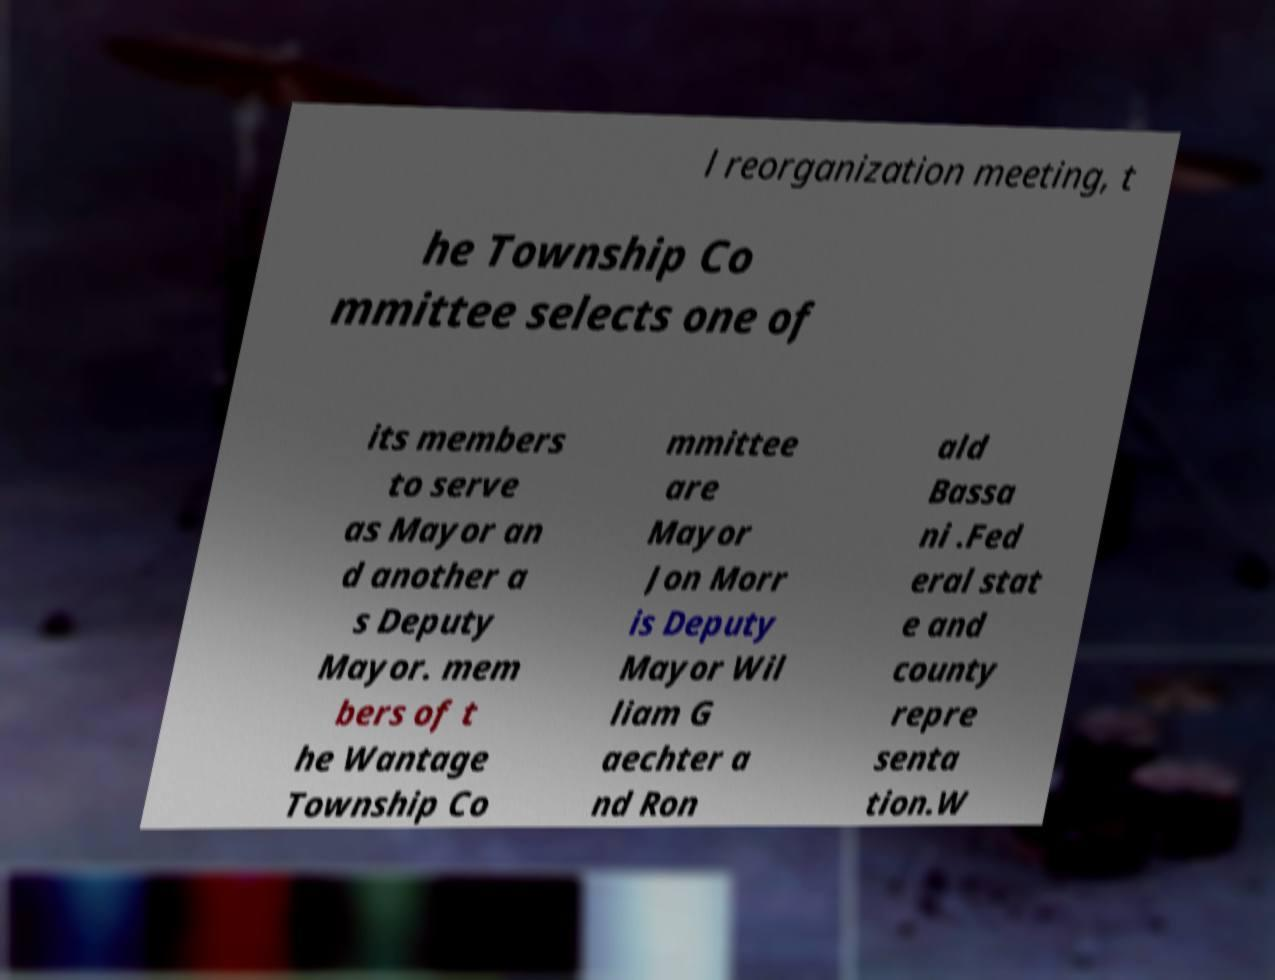What messages or text are displayed in this image? I need them in a readable, typed format. l reorganization meeting, t he Township Co mmittee selects one of its members to serve as Mayor an d another a s Deputy Mayor. mem bers of t he Wantage Township Co mmittee are Mayor Jon Morr is Deputy Mayor Wil liam G aechter a nd Ron ald Bassa ni .Fed eral stat e and county repre senta tion.W 